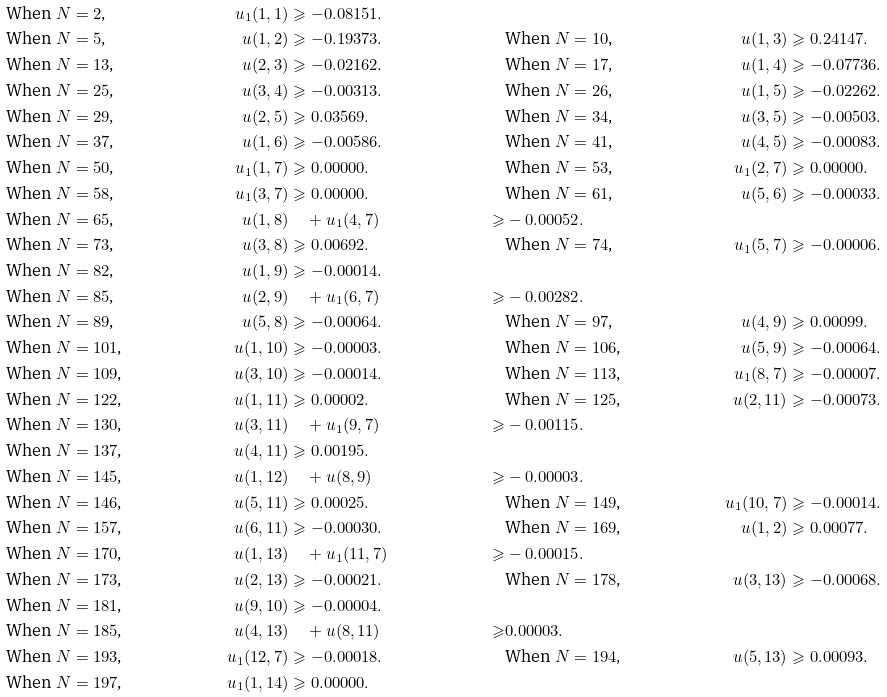Convert formula to latex. <formula><loc_0><loc_0><loc_500><loc_500>& \text {When $N = 2$,} & u _ { 1 } ( 1 , 1 ) & \geqslant - 0 . 0 8 1 5 1 . \\ & \text {When $N = 5$,} & u ( 1 , 2 ) & \geqslant - 0 . 1 9 3 7 3 . & & \text {When $N = 10$,} & u ( 1 , 3 ) & \geqslant 0 . 2 4 1 4 7 . \\ & \text {When $N = 13$,} & u ( 2 , 3 ) & \geqslant - 0 . 0 2 1 6 2 . & & \text {When $N = 17$,} & u ( 1 , 4 ) & \geqslant - 0 . 0 7 7 3 6 . \\ & \text {When $N = 25$,} & u ( 3 , 4 ) & \geqslant - 0 . 0 0 3 1 3 . & & \text {When $N = 26$,} & u ( 1 , 5 ) & \geqslant - 0 . 0 2 2 6 2 . \\ & \text {When $N = 29$,} & u ( 2 , 5 ) & \geqslant 0 . 0 3 5 6 9 . & & \text {When $N = 34$,} & u ( 3 , 5 ) & \geqslant - 0 . 0 0 5 0 3 . \\ & \text {When $N = 37$,} & u ( 1 , 6 ) & \geqslant - 0 . 0 0 5 8 6 . & & \text {When $N = 41$,} & u ( 4 , 5 ) & \geqslant - 0 . 0 0 0 8 3 . \\ & \text {When $N = 50$,} & u _ { 1 } ( 1 , 7 ) & \geqslant 0 . 0 0 0 0 0 . & & \text {When $N = 53$,} & u _ { 1 } ( 2 , 7 ) & \geqslant 0 . 0 0 0 0 0 . \\ & \text {When $N = 58$,} & u _ { 1 } ( 3 , 7 ) & \geqslant 0 . 0 0 0 0 0 . & & \text {When $N = 61$,} & u ( 5 , 6 ) & \geqslant - 0 . 0 0 0 3 3 . \\ & \text {When $N = 65$,} & u ( 1 , 8 ) & \quad + u _ { 1 } ( 4 , 7 ) & \geqslant & - 0 . 0 0 0 5 2 . \\ & \text {When $N = 73$,} & u ( 3 , 8 ) & \geqslant 0 . 0 0 6 9 2 . & & \text {When $N = 74$,} & u _ { 1 } ( 5 , 7 ) & \geqslant - 0 . 0 0 0 0 6 . \\ & \text {When $N = 82$,} & u ( 1 , 9 ) & \geqslant - 0 . 0 0 0 1 4 . \\ & \text {When $N = 85$,} & u ( 2 , 9 ) & \quad + u _ { 1 } ( 6 , 7 ) & \geqslant & - 0 . 0 0 2 8 2 . \\ & \text {When $N = 89$,} & u ( 5 , 8 ) & \geqslant - 0 . 0 0 0 6 4 . & & \text {When $N = 97$,} & u ( 4 , 9 ) & \geqslant 0 . 0 0 0 9 9 . \\ & \text {When $N = 101$,} & u ( 1 , 1 0 ) & \geqslant - 0 . 0 0 0 0 3 . & & \text {When $N = 106$,} & u ( 5 , 9 ) & \geqslant - 0 . 0 0 0 6 4 . \\ & \text {When $N = 109$,} & u ( 3 , 1 0 ) & \geqslant - 0 . 0 0 0 1 4 . & & \text {When $N = 113$,} & u _ { 1 } ( 8 , 7 ) & \geqslant - 0 . 0 0 0 0 7 . \\ & \text {When $N = 122$,} & u ( 1 , 1 1 ) & \geqslant 0 . 0 0 0 0 2 . & & \text {When $N = 125$,} & u ( 2 , 1 1 ) & \geqslant - 0 . 0 0 0 7 3 . \\ & \text {When $N = 130$,} & u ( 3 , 1 1 ) & \quad + u _ { 1 } ( 9 , 7 ) & \geqslant & - 0 . 0 0 1 1 5 . \\ & \text {When $N = 137$,} & u ( 4 , 1 1 ) & \geqslant 0 . 0 0 1 9 5 . \\ & \text {When $N = 145$,} & u ( 1 , 1 2 ) & \quad + u ( 8 , 9 ) & \geqslant & - 0 . 0 0 0 0 3 . \\ & \text {When $N = 146$,} & u ( 5 , 1 1 ) & \geqslant 0 . 0 0 0 2 5 . & & \text {When $N = 149$,} & u _ { 1 } ( 1 0 , 7 ) & \geqslant - 0 . 0 0 0 1 4 . \\ & \text {When $N = 157$,} & u ( 6 , 1 1 ) & \geqslant - 0 . 0 0 0 3 0 . & & \text {When $N = 169$,} & u ( 1 , 2 ) & \geqslant 0 . 0 0 0 7 7 . \\ & \text {When $N = 170$,} & u ( 1 , 1 3 ) & \quad + u _ { 1 } ( 1 1 , 7 ) & \geqslant & - 0 . 0 0 0 1 5 . \\ & \text {When $N = 173$,} & u ( 2 , 1 3 ) & \geqslant - 0 . 0 0 0 2 1 . & & \text {When $N = 178$,} & u ( 3 , 1 3 ) & \geqslant - 0 . 0 0 0 6 8 . \\ & \text {When $N = 181$,} & u ( 9 , 1 0 ) & \geqslant - 0 . 0 0 0 0 4 . \\ & \text {When $N = 185$,} & u ( 4 , 1 3 ) & \quad + u ( 8 , 1 1 ) & \geqslant & 0 . 0 0 0 0 3 . \\ & \text {When $N = 193$,} & u _ { 1 } ( 1 2 , 7 ) & \geqslant - 0 . 0 0 0 1 8 . & & \text {When $N = 194$,} & u ( 5 , 1 3 ) & \geqslant 0 . 0 0 0 9 3 . \\ & \text {When $N = 197$,} & u _ { 1 } ( 1 , 1 4 ) & \geqslant 0 . 0 0 0 0 0 .</formula> 